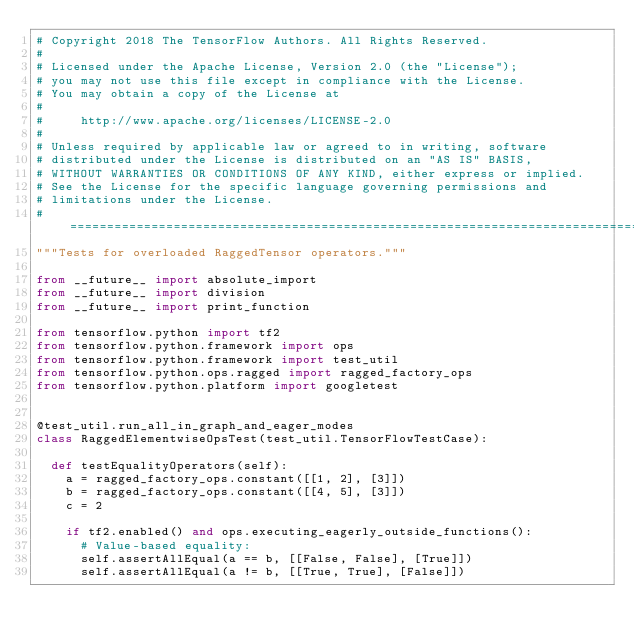Convert code to text. <code><loc_0><loc_0><loc_500><loc_500><_Python_># Copyright 2018 The TensorFlow Authors. All Rights Reserved.
#
# Licensed under the Apache License, Version 2.0 (the "License");
# you may not use this file except in compliance with the License.
# You may obtain a copy of the License at
#
#     http://www.apache.org/licenses/LICENSE-2.0
#
# Unless required by applicable law or agreed to in writing, software
# distributed under the License is distributed on an "AS IS" BASIS,
# WITHOUT WARRANTIES OR CONDITIONS OF ANY KIND, either express or implied.
# See the License for the specific language governing permissions and
# limitations under the License.
# ==============================================================================
"""Tests for overloaded RaggedTensor operators."""

from __future__ import absolute_import
from __future__ import division
from __future__ import print_function

from tensorflow.python import tf2
from tensorflow.python.framework import ops
from tensorflow.python.framework import test_util
from tensorflow.python.ops.ragged import ragged_factory_ops
from tensorflow.python.platform import googletest


@test_util.run_all_in_graph_and_eager_modes
class RaggedElementwiseOpsTest(test_util.TensorFlowTestCase):

  def testEqualityOperators(self):
    a = ragged_factory_ops.constant([[1, 2], [3]])
    b = ragged_factory_ops.constant([[4, 5], [3]])
    c = 2

    if tf2.enabled() and ops.executing_eagerly_outside_functions():
      # Value-based equality:
      self.assertAllEqual(a == b, [[False, False], [True]])
      self.assertAllEqual(a != b, [[True, True], [False]])
</code> 